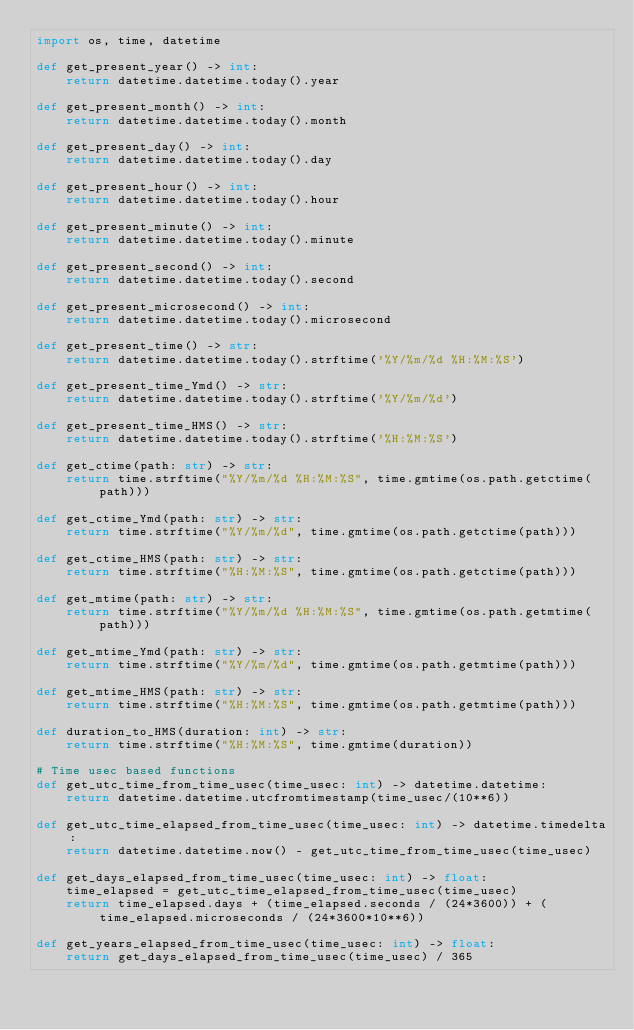<code> <loc_0><loc_0><loc_500><loc_500><_Python_>import os, time, datetime

def get_present_year() -> int:
    return datetime.datetime.today().year

def get_present_month() -> int:
    return datetime.datetime.today().month

def get_present_day() -> int:
    return datetime.datetime.today().day

def get_present_hour() -> int:
    return datetime.datetime.today().hour

def get_present_minute() -> int:
    return datetime.datetime.today().minute

def get_present_second() -> int:
    return datetime.datetime.today().second

def get_present_microsecond() -> int:
    return datetime.datetime.today().microsecond

def get_present_time() -> str:
    return datetime.datetime.today().strftime('%Y/%m/%d %H:%M:%S')

def get_present_time_Ymd() -> str:
    return datetime.datetime.today().strftime('%Y/%m/%d')

def get_present_time_HMS() -> str:
    return datetime.datetime.today().strftime('%H:%M:%S')

def get_ctime(path: str) -> str:
    return time.strftime("%Y/%m/%d %H:%M:%S", time.gmtime(os.path.getctime(path)))

def get_ctime_Ymd(path: str) -> str:
    return time.strftime("%Y/%m/%d", time.gmtime(os.path.getctime(path)))

def get_ctime_HMS(path: str) -> str:
    return time.strftime("%H:%M:%S", time.gmtime(os.path.getctime(path)))

def get_mtime(path: str) -> str:
    return time.strftime("%Y/%m/%d %H:%M:%S", time.gmtime(os.path.getmtime(path)))

def get_mtime_Ymd(path: str) -> str:
    return time.strftime("%Y/%m/%d", time.gmtime(os.path.getmtime(path)))

def get_mtime_HMS(path: str) -> str:
    return time.strftime("%H:%M:%S", time.gmtime(os.path.getmtime(path)))

def duration_to_HMS(duration: int) -> str:
    return time.strftime("%H:%M:%S", time.gmtime(duration))

# Time usec based functions
def get_utc_time_from_time_usec(time_usec: int) -> datetime.datetime:
    return datetime.datetime.utcfromtimestamp(time_usec/(10**6))

def get_utc_time_elapsed_from_time_usec(time_usec: int) -> datetime.timedelta:
    return datetime.datetime.now() - get_utc_time_from_time_usec(time_usec)

def get_days_elapsed_from_time_usec(time_usec: int) -> float:
    time_elapsed = get_utc_time_elapsed_from_time_usec(time_usec)
    return time_elapsed.days + (time_elapsed.seconds / (24*3600)) + (time_elapsed.microseconds / (24*3600*10**6))

def get_years_elapsed_from_time_usec(time_usec: int) -> float:
    return get_days_elapsed_from_time_usec(time_usec) / 365</code> 